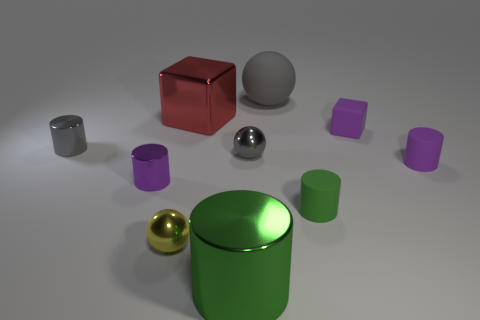Subtract all green rubber cylinders. How many cylinders are left? 4 Subtract all cyan cylinders. How many gray spheres are left? 2 Subtract all yellow spheres. How many spheres are left? 2 Subtract all blocks. How many objects are left? 8 Subtract 3 cylinders. How many cylinders are left? 2 Subtract all small blue cylinders. Subtract all small gray metal balls. How many objects are left? 9 Add 7 big red cubes. How many big red cubes are left? 8 Add 1 big balls. How many big balls exist? 2 Subtract 2 green cylinders. How many objects are left? 8 Subtract all red cylinders. Subtract all purple spheres. How many cylinders are left? 5 